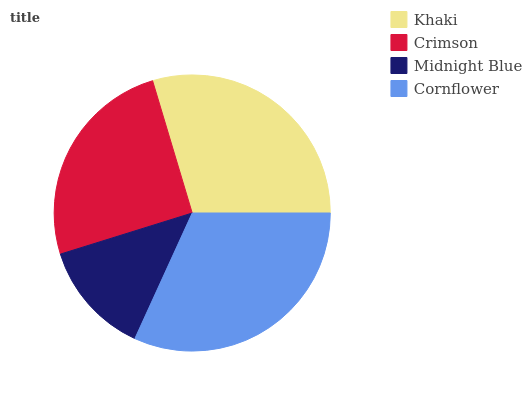Is Midnight Blue the minimum?
Answer yes or no. Yes. Is Cornflower the maximum?
Answer yes or no. Yes. Is Crimson the minimum?
Answer yes or no. No. Is Crimson the maximum?
Answer yes or no. No. Is Khaki greater than Crimson?
Answer yes or no. Yes. Is Crimson less than Khaki?
Answer yes or no. Yes. Is Crimson greater than Khaki?
Answer yes or no. No. Is Khaki less than Crimson?
Answer yes or no. No. Is Khaki the high median?
Answer yes or no. Yes. Is Crimson the low median?
Answer yes or no. Yes. Is Midnight Blue the high median?
Answer yes or no. No. Is Cornflower the low median?
Answer yes or no. No. 